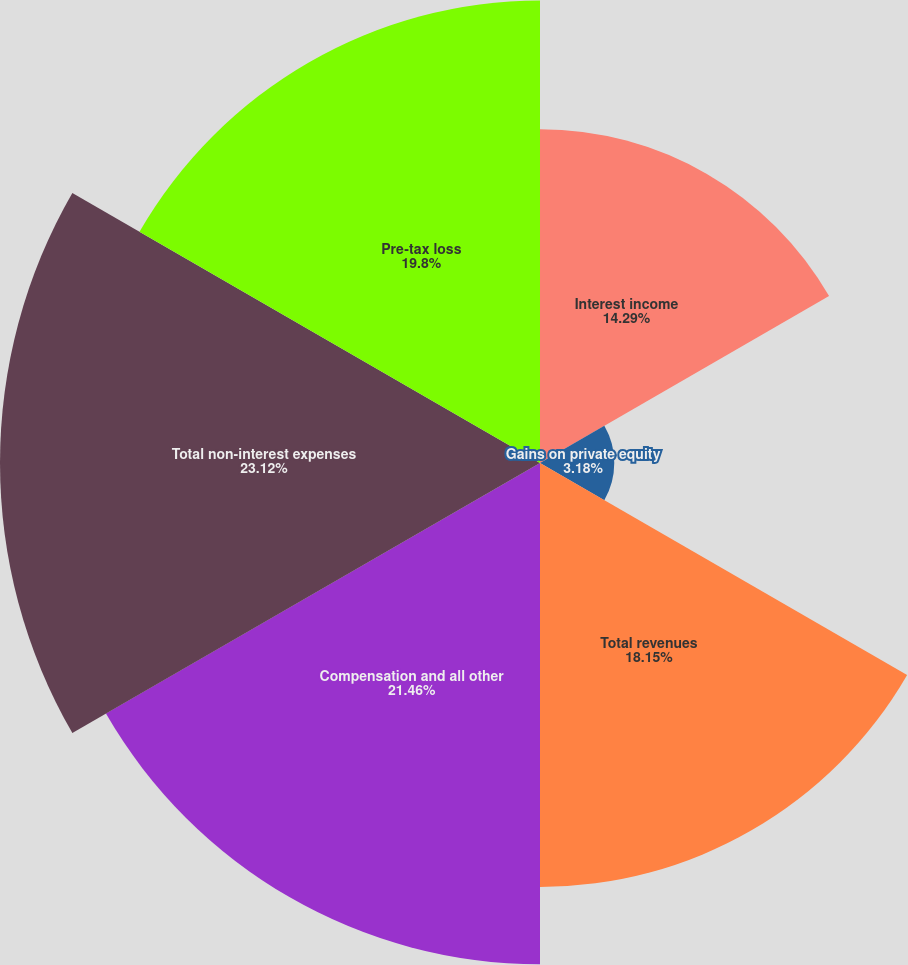<chart> <loc_0><loc_0><loc_500><loc_500><pie_chart><fcel>Interest income<fcel>Gains on private equity<fcel>Total revenues<fcel>Compensation and all other<fcel>Total non-interest expenses<fcel>Pre-tax loss<nl><fcel>14.29%<fcel>3.18%<fcel>18.15%<fcel>21.46%<fcel>23.12%<fcel>19.8%<nl></chart> 